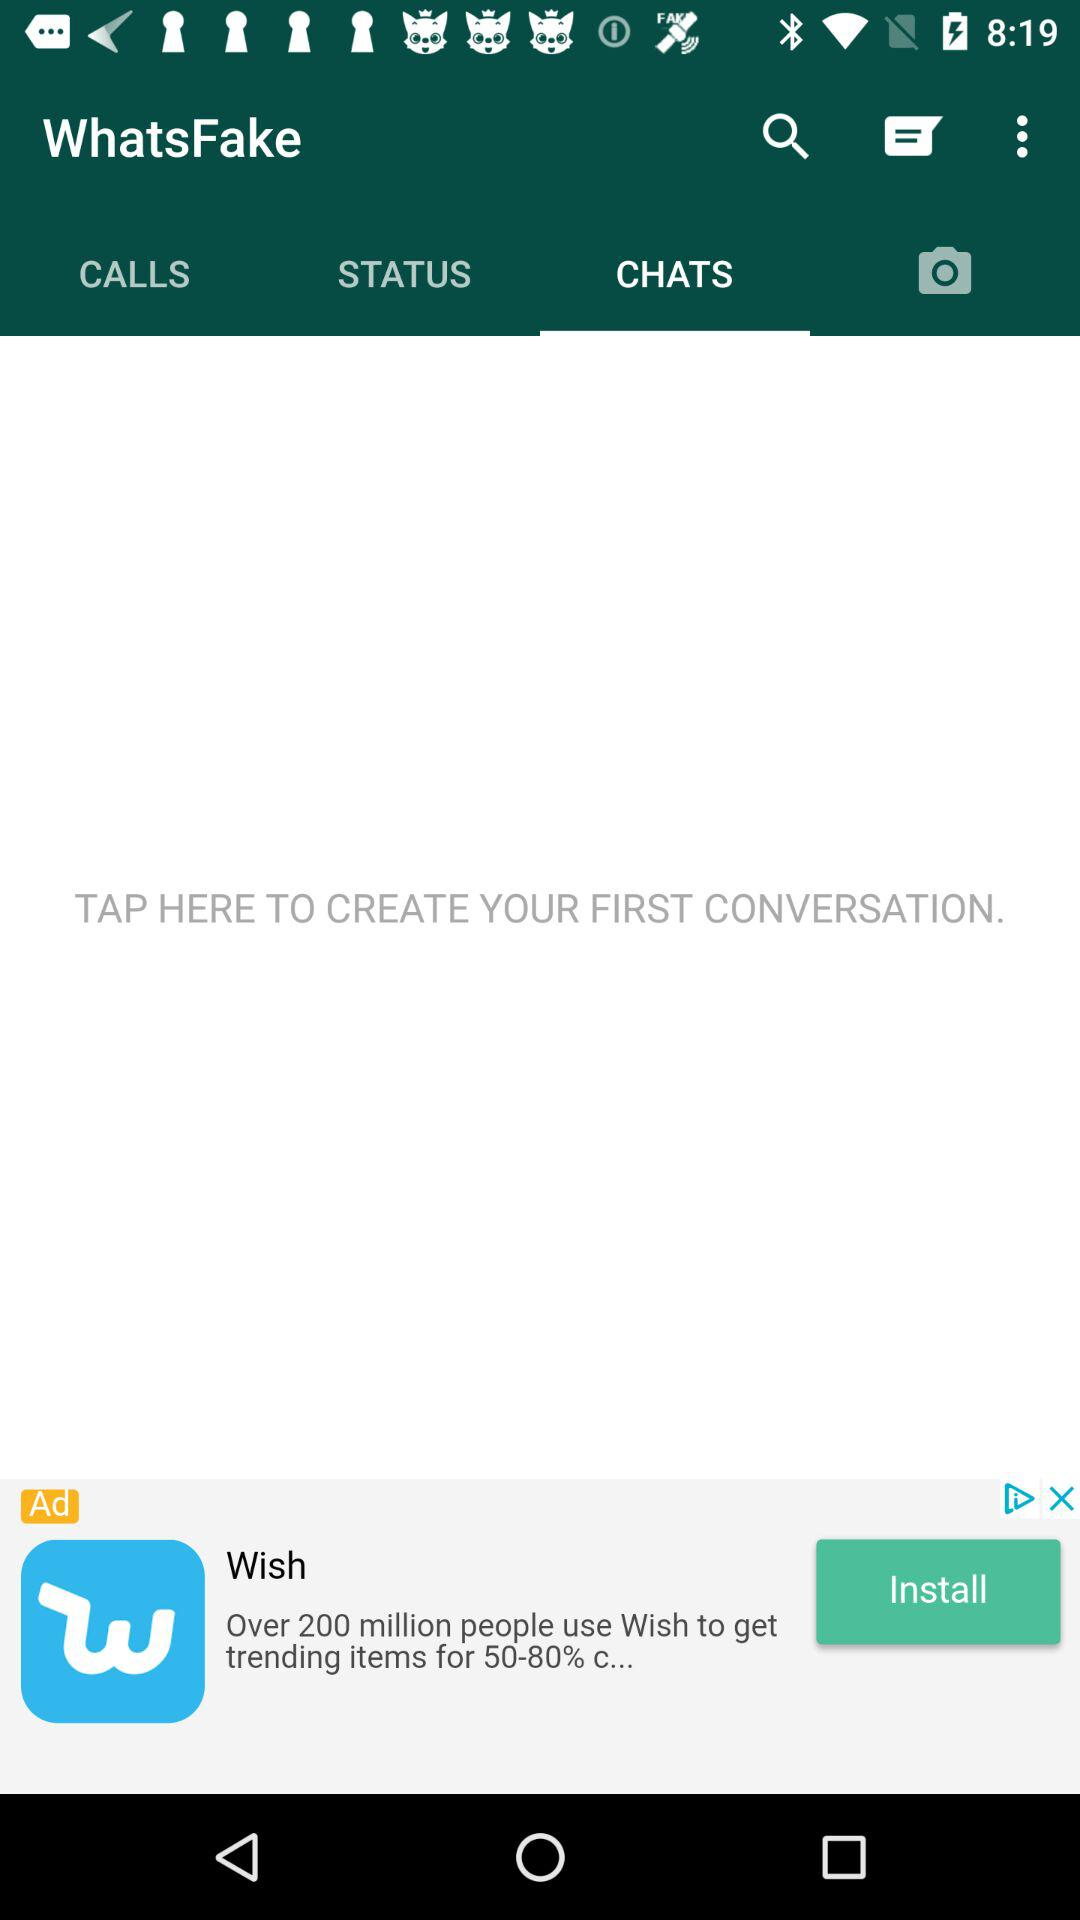What is the application name? The application name is "WhatsFake". 